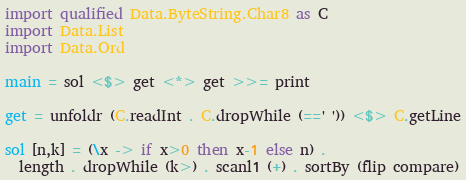<code> <loc_0><loc_0><loc_500><loc_500><_Haskell_>import qualified Data.ByteString.Char8 as C
import Data.List
import Data.Ord

main = sol <$> get <*> get >>= print

get = unfoldr (C.readInt . C.dropWhile (==' ')) <$> C.getLine

sol [n,k] = (\x -> if x>0 then x-1 else n) . 
  length . dropWhile (k>) . scanl1 (+) . sortBy (flip compare)</code> 